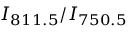<formula> <loc_0><loc_0><loc_500><loc_500>I _ { 8 1 1 . 5 } / I _ { 7 5 0 . 5 }</formula> 